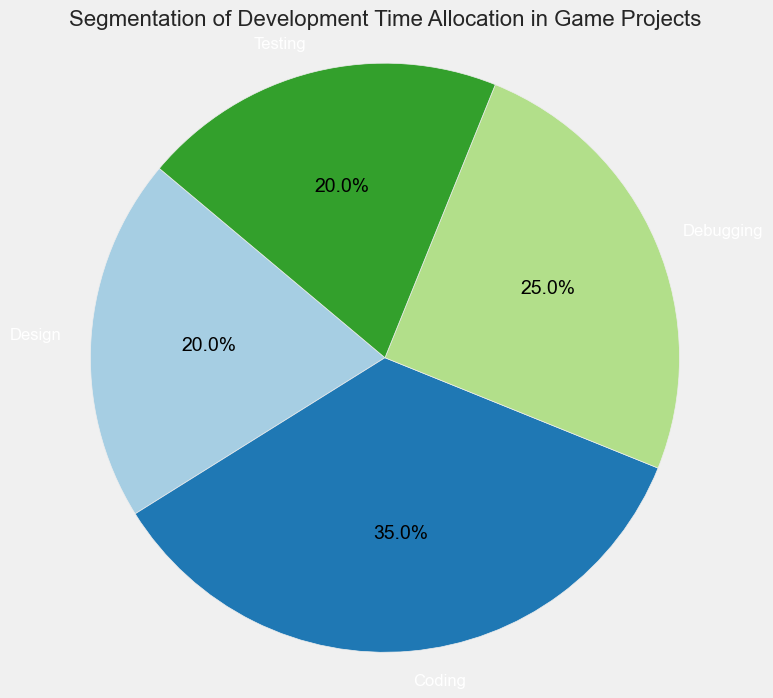What percentage of time is allocated to both Design and Testing combined? The figure shows that Design is allocated 20% of the total time and Testing is also allocated 20%. Adding these two percentages together, we get 20% + 20% = 40%.
Answer: 40% Which activity has the largest allocation of development time? The figure indicates that Coding has the highest allocated percentage, which is 35%.
Answer: Coding What is the difference in time allocation between Debugging and Design? The pie chart shows that Debugging is allocated 25% and Design is allocated 20%. The difference is 25% - 20% = 5%.
Answer: 5% How much more time is spent on Coding compared to Testing? The figure shows that Coding is allocated 35%, while Testing is allocated 20%. The difference is 35% - 20% = 15%.
Answer: 15% Which two activities have the same percentage of time allocation? The pie chart shows that both Design and Testing are allocated the same percentage, which is 20%.
Answer: Design and Testing What is the total percentage of time allocated to Debugging and Coding? According to the pie chart, Debugging is 25% and Coding is 35%. Adding these, we get 25% + 35% = 60%.
Answer: 60% If you combine the time allocated to Design and Testing, how does it compare to the time allocated to Coding? The time allocated to Design and Testing combined is 20% + 20% = 40%. The time allocated to Coding alone is 35%. Therefore, 40% (Design + Testing) > 35% (Coding).
Answer: Design + Testing > Coding Which activity has the smallest allocation of development time? The categories of Design and Testing both have the smallest allocations, each at 20%.
Answer: Design and Testing What fraction of the total time is spent on Debugging? The pie chart shows that Debugging takes up 25% of the total time. As a fraction, this is 25/100, which simplifies to 1/4.
Answer: 1/4 